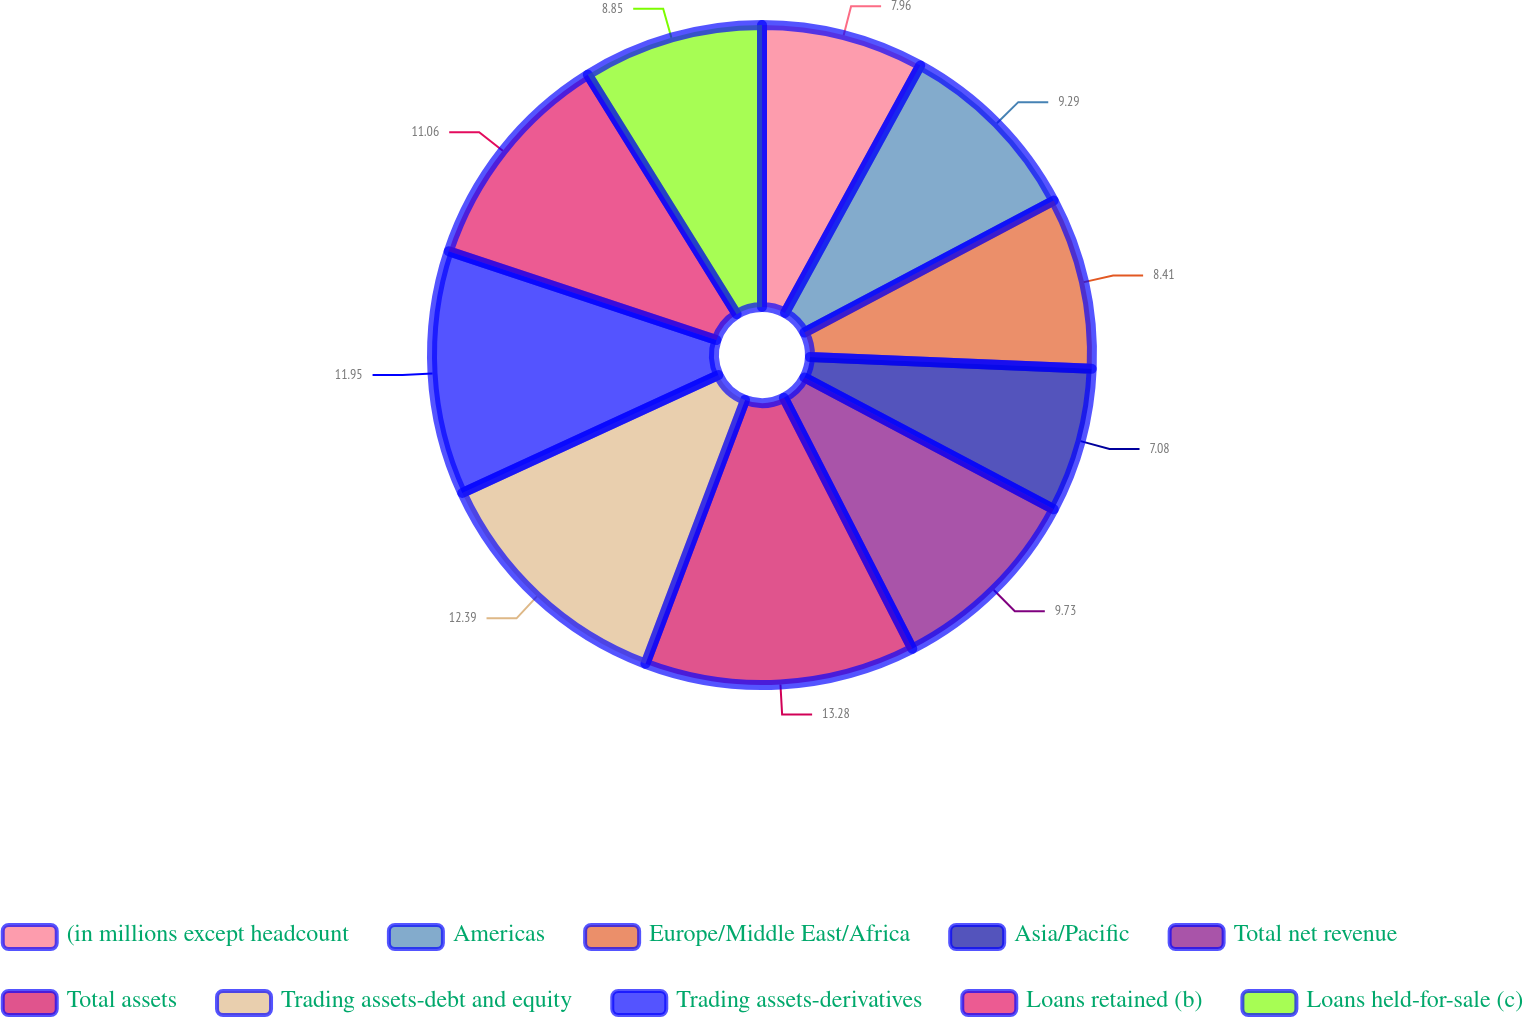Convert chart to OTSL. <chart><loc_0><loc_0><loc_500><loc_500><pie_chart><fcel>(in millions except headcount<fcel>Americas<fcel>Europe/Middle East/Africa<fcel>Asia/Pacific<fcel>Total net revenue<fcel>Total assets<fcel>Trading assets-debt and equity<fcel>Trading assets-derivatives<fcel>Loans retained (b)<fcel>Loans held-for-sale (c)<nl><fcel>7.96%<fcel>9.29%<fcel>8.41%<fcel>7.08%<fcel>9.73%<fcel>13.27%<fcel>12.39%<fcel>11.95%<fcel>11.06%<fcel>8.85%<nl></chart> 